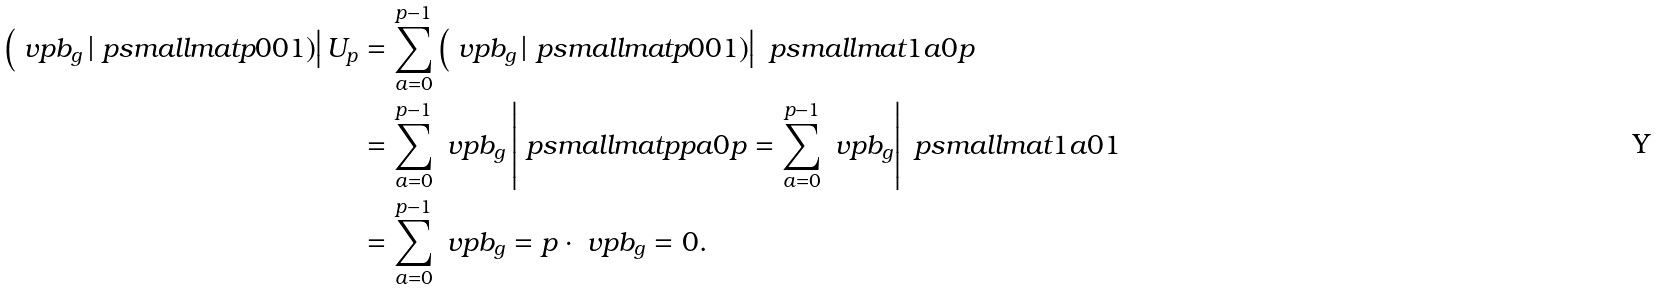Convert formula to latex. <formula><loc_0><loc_0><loc_500><loc_500>\left ( \ v p b _ { g } \left | \ p s m a l l m a t { p } { 0 } { 0 } { 1 } \right ) \right | U _ { p } & = \sum _ { a = 0 } ^ { p - 1 } \left ( \ v p b _ { g } \left | \ p s m a l l m a t { p } { 0 } { 0 } { 1 } \right ) \right | \ p s m a l l m a t { 1 } { a } { 0 } { p } \\ & = \sum _ { a = 0 } ^ { p - 1 } \ v p b _ { g } \left | \ p s m a l l m a t { p } { p a } { 0 } { p } = \sum _ { a = 0 } ^ { p - 1 } \ v p b _ { g } \right | \ p s m a l l m a t { 1 } { a } { 0 } { 1 } \\ & = \sum _ { a = 0 } ^ { p - 1 } \ v p b _ { g } = p \cdot \ v p b _ { g } = 0 .</formula> 